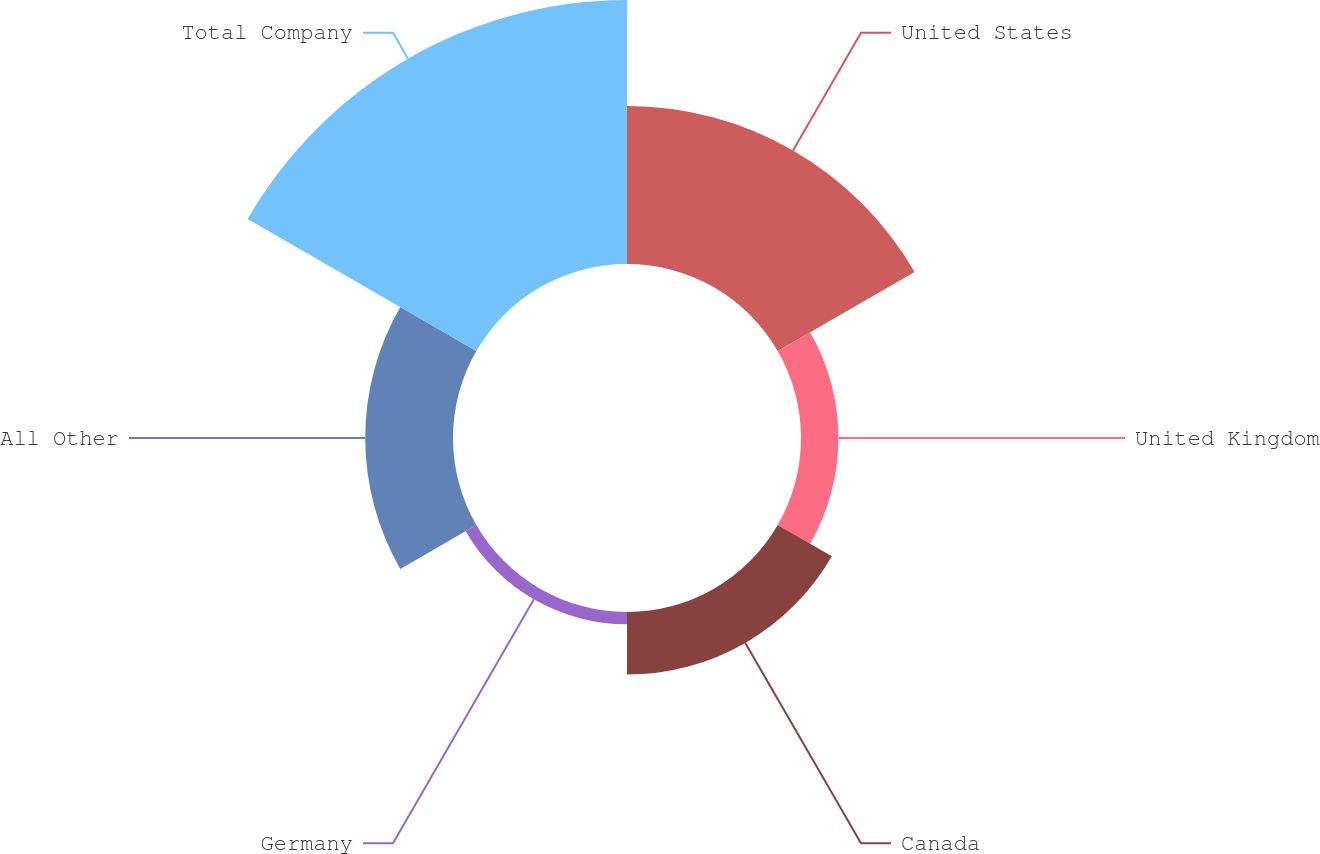Convert chart. <chart><loc_0><loc_0><loc_500><loc_500><pie_chart><fcel>United States<fcel>United Kingdom<fcel>Canada<fcel>Germany<fcel>All Other<fcel>Total Company<nl><fcel>25.41%<fcel>6.01%<fcel>10.06%<fcel>1.97%<fcel>14.11%<fcel>42.44%<nl></chart> 